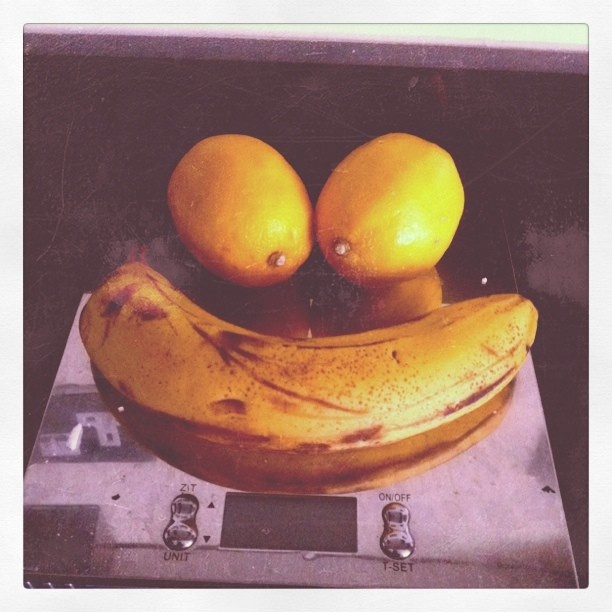Describe the objects in this image and their specific colors. I can see banana in whitesmoke, orange, brown, and salmon tones, orange in whitesmoke, orange, brown, gold, and salmon tones, and orange in whitesmoke, khaki, orange, and salmon tones in this image. 